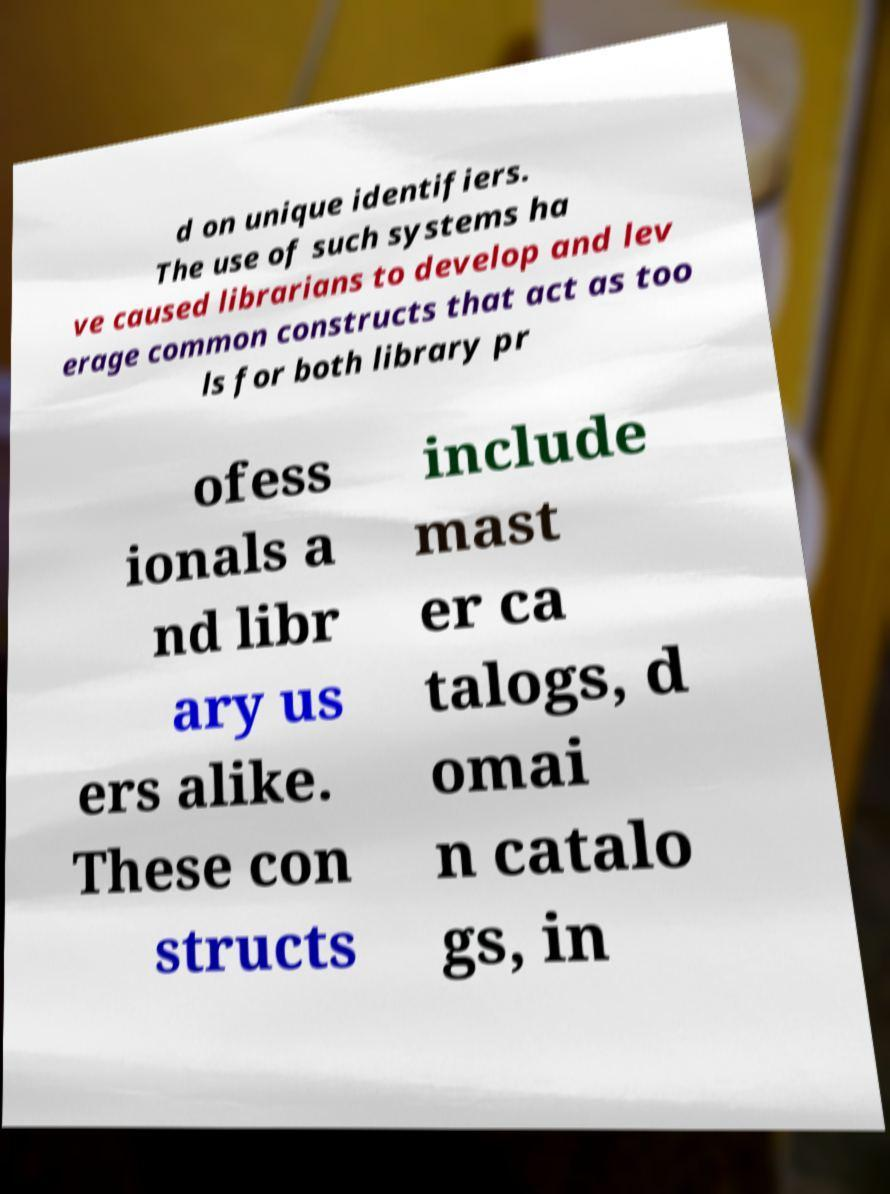I need the written content from this picture converted into text. Can you do that? d on unique identifiers. The use of such systems ha ve caused librarians to develop and lev erage common constructs that act as too ls for both library pr ofess ionals a nd libr ary us ers alike. These con structs include mast er ca talogs, d omai n catalo gs, in 